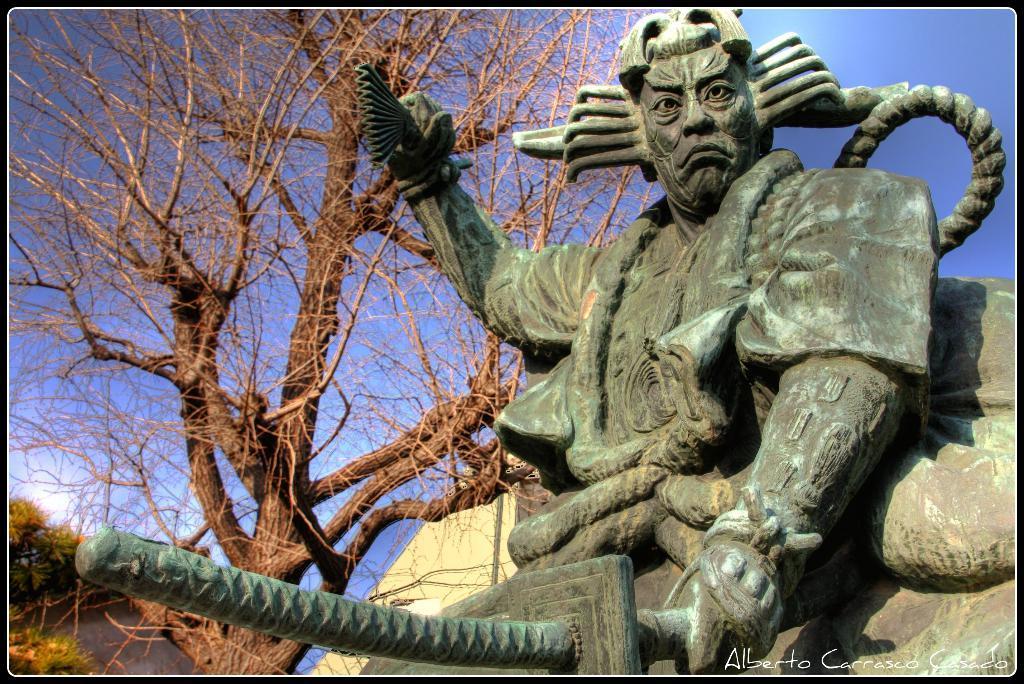Please provide a concise description of this image. In this image there is the sky towards the top of the image, there are trees, there is a sculpture of a man, he is holding a sword, there is text towards the bottom of the image. 